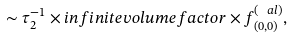Convert formula to latex. <formula><loc_0><loc_0><loc_500><loc_500>\sim \tau _ { 2 } ^ { - 1 } \times i n f i n i t e v o l u m e f a c t o r \times f ^ { ( \ a l ) } _ { ( 0 , 0 ) } ,</formula> 